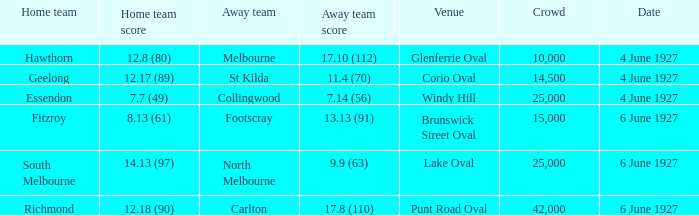Which location is home to the geelong team? Corio Oval. 